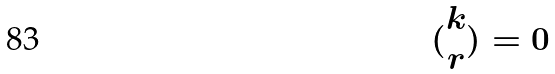Convert formula to latex. <formula><loc_0><loc_0><loc_500><loc_500>( \begin{matrix} k \\ r \end{matrix} ) = 0</formula> 